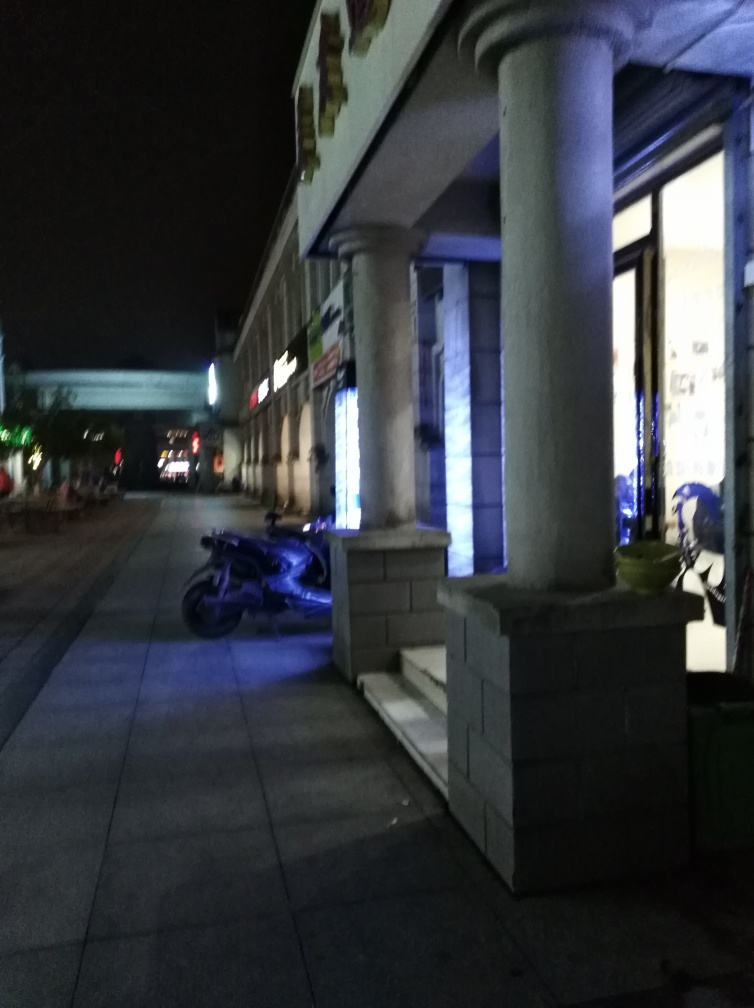What kind of atmosphere does the lighting in this image create? The lighting in the image creates a serene and somewhat mysterious atmosphere. The soft blue lights emanating from the storefront and their reflection on the ground contribute to a calm and cool ambiance, while the darkness in the rest of the scene provides a quiet, almost secretive feel to the setting. Can you suggest what time of day it might be? Given the lack of natural light and the illuminated storefront, it suggests that the photo was taken at night. The absence of people and the darkness of the sky further support that it's likely to be late evening or nighttime. 